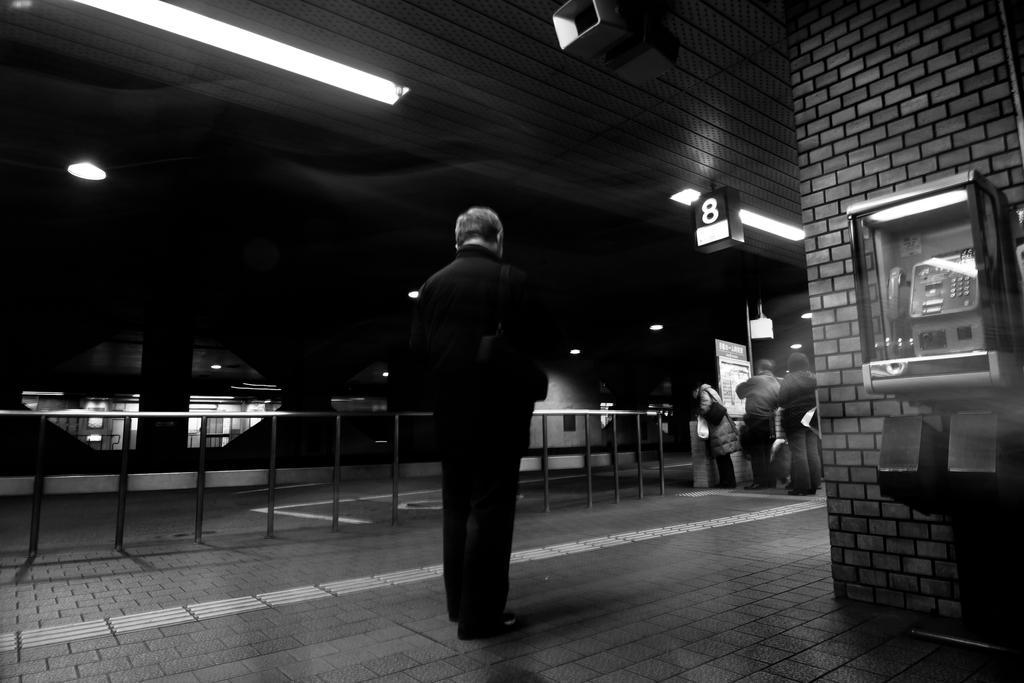Describe this image in one or two sentences. This picture shows a few people are standing in a line and we see a woman wore handbag and we see another man standing on the side, He wore a backpack and we see a telephone in the glass box and few lights to the ceiling. 